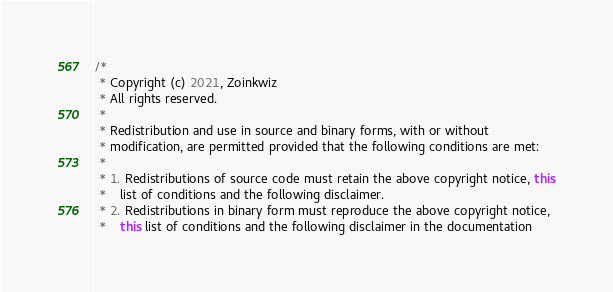Convert code to text. <code><loc_0><loc_0><loc_500><loc_500><_Java_>/*
 * Copyright (c) 2021, Zoinkwiz
 * All rights reserved.
 *
 * Redistribution and use in source and binary forms, with or without
 * modification, are permitted provided that the following conditions are met:
 *
 * 1. Redistributions of source code must retain the above copyright notice, this
 *    list of conditions and the following disclaimer.
 * 2. Redistributions in binary form must reproduce the above copyright notice,
 *    this list of conditions and the following disclaimer in the documentation</code> 